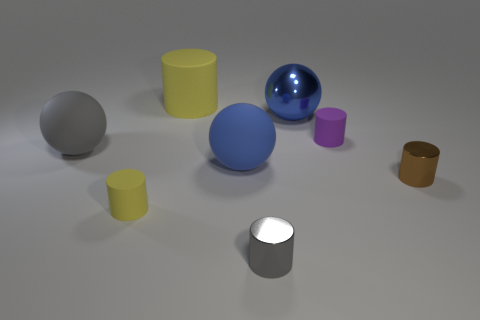Subtract all tiny brown cylinders. How many cylinders are left? 4 Subtract all gray cylinders. How many cylinders are left? 4 Subtract all cyan cylinders. Subtract all yellow spheres. How many cylinders are left? 5 Add 1 small gray things. How many objects exist? 9 Subtract all balls. How many objects are left? 5 Subtract 1 brown cylinders. How many objects are left? 7 Subtract all big purple cubes. Subtract all yellow things. How many objects are left? 6 Add 5 big yellow rubber objects. How many big yellow rubber objects are left? 6 Add 7 big gray balls. How many big gray balls exist? 8 